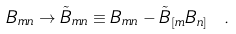<formula> <loc_0><loc_0><loc_500><loc_500>B _ { m n } \rightarrow \tilde { B } _ { m n } \equiv B _ { m n } - { \tilde { B } } _ { [ m } B _ { n ] } \ .</formula> 